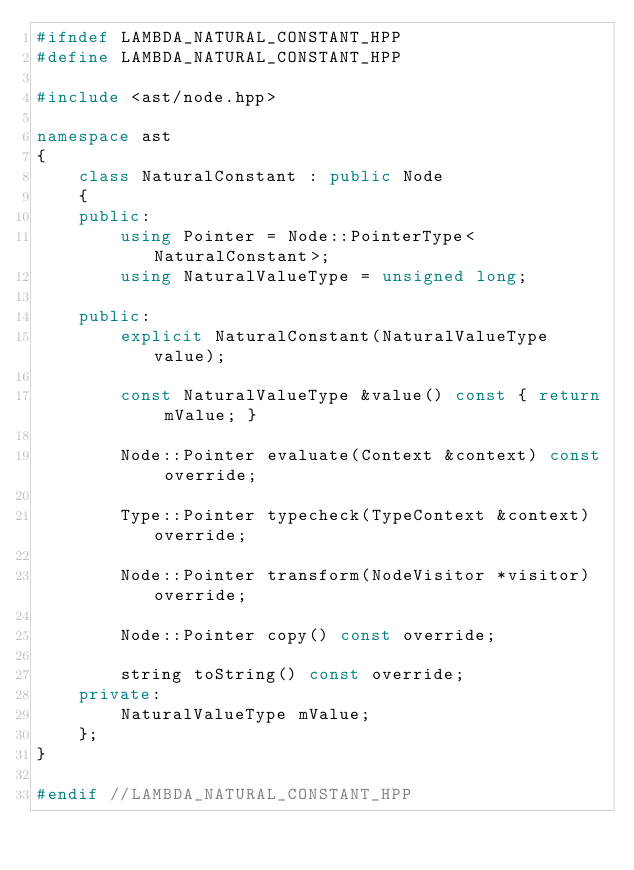Convert code to text. <code><loc_0><loc_0><loc_500><loc_500><_C++_>#ifndef LAMBDA_NATURAL_CONSTANT_HPP
#define LAMBDA_NATURAL_CONSTANT_HPP

#include <ast/node.hpp>

namespace ast
{
    class NaturalConstant : public Node
    {
    public:
        using Pointer = Node::PointerType<NaturalConstant>;
        using NaturalValueType = unsigned long;

    public:
        explicit NaturalConstant(NaturalValueType value);

        const NaturalValueType &value() const { return mValue; }

        Node::Pointer evaluate(Context &context) const override;

        Type::Pointer typecheck(TypeContext &context) override;

        Node::Pointer transform(NodeVisitor *visitor) override;

        Node::Pointer copy() const override;

        string toString() const override;
    private:
        NaturalValueType mValue;
    };
}

#endif //LAMBDA_NATURAL_CONSTANT_HPP
</code> 